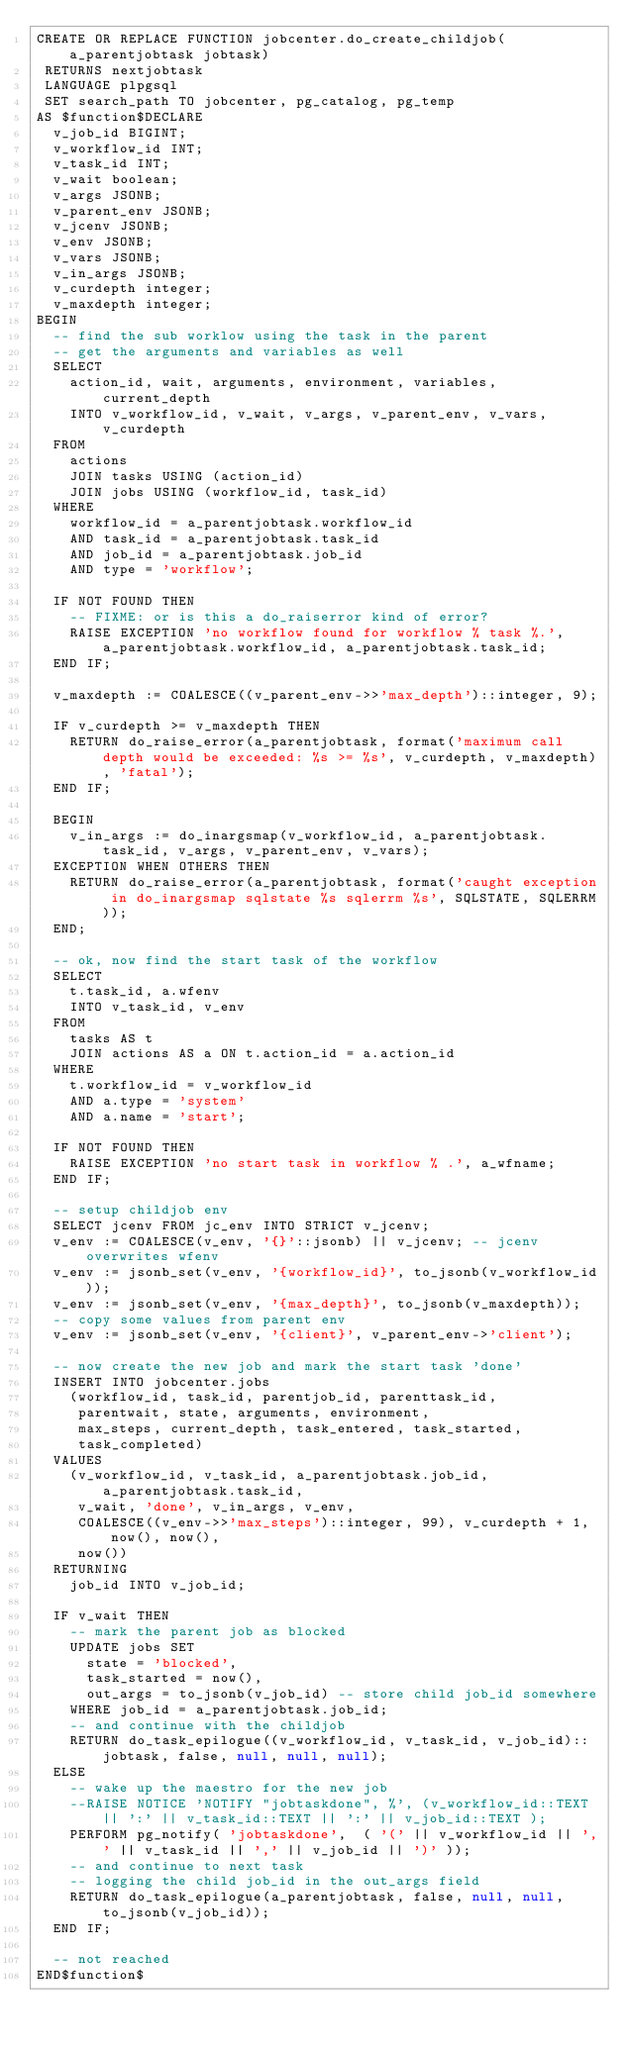Convert code to text. <code><loc_0><loc_0><loc_500><loc_500><_SQL_>CREATE OR REPLACE FUNCTION jobcenter.do_create_childjob(a_parentjobtask jobtask)
 RETURNS nextjobtask
 LANGUAGE plpgsql
 SET search_path TO jobcenter, pg_catalog, pg_temp
AS $function$DECLARE
	v_job_id BIGINT;
	v_workflow_id INT;
	v_task_id INT;
	v_wait boolean;
	v_args JSONB;
	v_parent_env JSONB;
	v_jcenv JSONB;
	v_env JSONB;
	v_vars JSONB;
	v_in_args JSONB;
	v_curdepth integer;
	v_maxdepth integer;
BEGIN
	-- find the sub worklow using the task in the parent
	-- get the arguments and variables as well
	SELECT
		action_id, wait, arguments, environment, variables, current_depth
		INTO v_workflow_id, v_wait, v_args, v_parent_env, v_vars, v_curdepth
	FROM 
		actions
		JOIN tasks USING (action_id)
		JOIN jobs USING (workflow_id, task_id)
	WHERE
		workflow_id = a_parentjobtask.workflow_id
		AND task_id = a_parentjobtask.task_id
		AND job_id = a_parentjobtask.job_id
		AND type = 'workflow';

	IF NOT FOUND THEN
		-- FIXME: or is this a do_raiserror kind of error?
		RAISE EXCEPTION 'no workflow found for workflow % task %.', a_parentjobtask.workflow_id, a_parentjobtask.task_id;
	END IF;

	v_maxdepth := COALESCE((v_parent_env->>'max_depth')::integer, 9);

	IF v_curdepth >= v_maxdepth THEN
		RETURN do_raise_error(a_parentjobtask, format('maximum call depth would be exceeded: %s >= %s', v_curdepth, v_maxdepth), 'fatal');
	END IF;

	BEGIN
		v_in_args := do_inargsmap(v_workflow_id, a_parentjobtask.task_id, v_args, v_parent_env, v_vars);
	EXCEPTION WHEN OTHERS THEN
		RETURN do_raise_error(a_parentjobtask, format('caught exception in do_inargsmap sqlstate %s sqlerrm %s', SQLSTATE, SQLERRM));
	END;
	
	-- ok, now find the start task of the workflow
	SELECT 
		t.task_id, a.wfenv
		INTO v_task_id, v_env
	FROM
		tasks AS t
		JOIN actions AS a ON t.action_id = a.action_id
	WHERE
		t.workflow_id = v_workflow_id
		AND a.type = 'system'
		AND a.name = 'start';

	IF NOT FOUND THEN
		RAISE EXCEPTION 'no start task in workflow % .', a_wfname;
	END IF;

	-- setup childjob env
	SELECT jcenv FROM jc_env INTO STRICT v_jcenv;
	v_env := COALESCE(v_env, '{}'::jsonb) || v_jcenv; -- jcenv overwrites wfenv
	v_env := jsonb_set(v_env, '{workflow_id}', to_jsonb(v_workflow_id));
	v_env := jsonb_set(v_env, '{max_depth}', to_jsonb(v_maxdepth));
	-- copy some values from parent env
	v_env := jsonb_set(v_env, '{client}', v_parent_env->'client');

	-- now create the new job and mark the start task 'done'
	INSERT INTO jobcenter.jobs
		(workflow_id, task_id, parentjob_id, parenttask_id,
		 parentwait, state, arguments, environment,
		 max_steps, current_depth, task_entered, task_started,
		 task_completed)
	VALUES
		(v_workflow_id, v_task_id, a_parentjobtask.job_id, a_parentjobtask.task_id,
		 v_wait, 'done', v_in_args, v_env,
		 COALESCE((v_env->>'max_steps')::integer, 99), v_curdepth + 1, now(), now(),
		 now())
	RETURNING
		job_id INTO v_job_id;

	IF v_wait THEN
		-- mark the parent job as blocked
		UPDATE jobs SET
			state = 'blocked',
			task_started = now(),
			out_args = to_jsonb(v_job_id) -- store child job_id somewhere
		WHERE job_id = a_parentjobtask.job_id;
		-- and continue with the childjob
		RETURN do_task_epilogue((v_workflow_id, v_task_id, v_job_id)::jobtask, false, null, null, null);
	ELSE
		-- wake up the maestro for the new job
		--RAISE NOTICE 'NOTIFY "jobtaskdone", %', (v_workflow_id::TEXT || ':' || v_task_id::TEXT || ':' || v_job_id::TEXT );
		PERFORM pg_notify( 'jobtaskdone',  ( '(' || v_workflow_id || ',' || v_task_id || ',' || v_job_id || ')' ));
		-- and continue to next task
		-- logging the child job_id in the out_args field
		RETURN do_task_epilogue(a_parentjobtask, false, null, null, to_jsonb(v_job_id));
	END IF;
	
	-- not reached
END$function$
</code> 